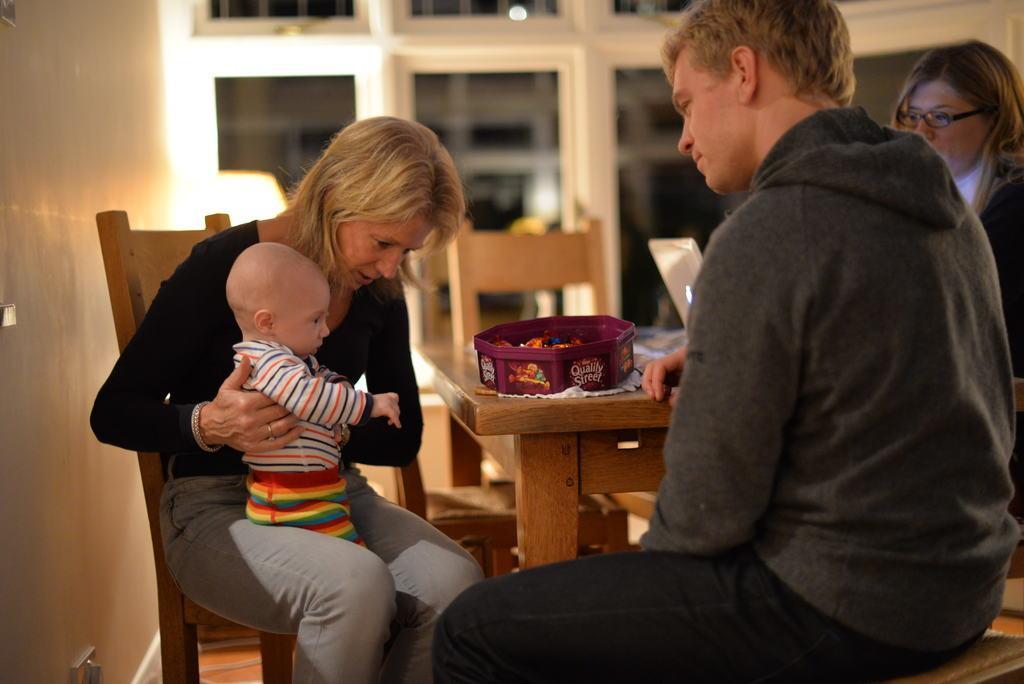How would you summarize this image in a sentence or two? In this image I can see a woman sitting on the chair and carrying a baby in her hands. On the right side of the image there is a man sitting on the bench in front of the table. Beside this person there is another woman looking at the baby. In the background there is a wall. On the table there is a box. 